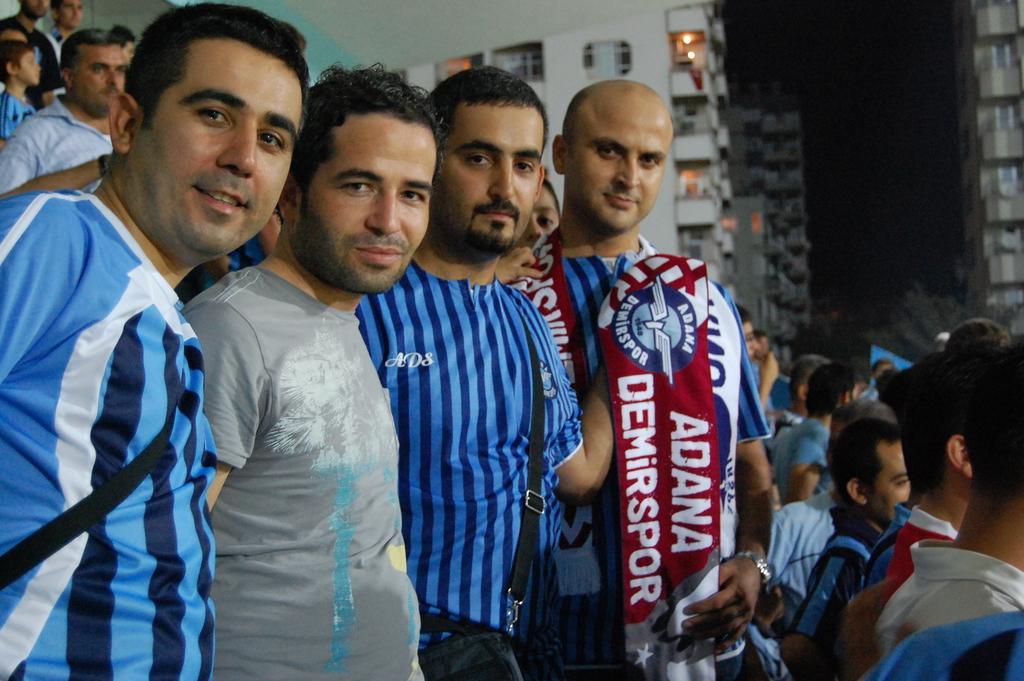Please provide a concise description of this image. In this picture, there are four men towards the left. All the men are wearing blue t shirts, except the man in the center wearing a grey t shirt. One of the man is holding a banner. Towards the right, there are people. In the background, there are buildings and people. 